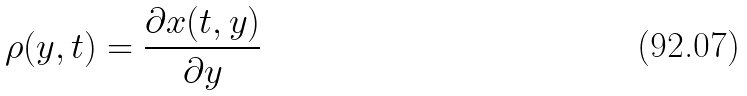<formula> <loc_0><loc_0><loc_500><loc_500>\rho ( y , t ) = \frac { \partial x ( t , y ) } { \partial y }</formula> 